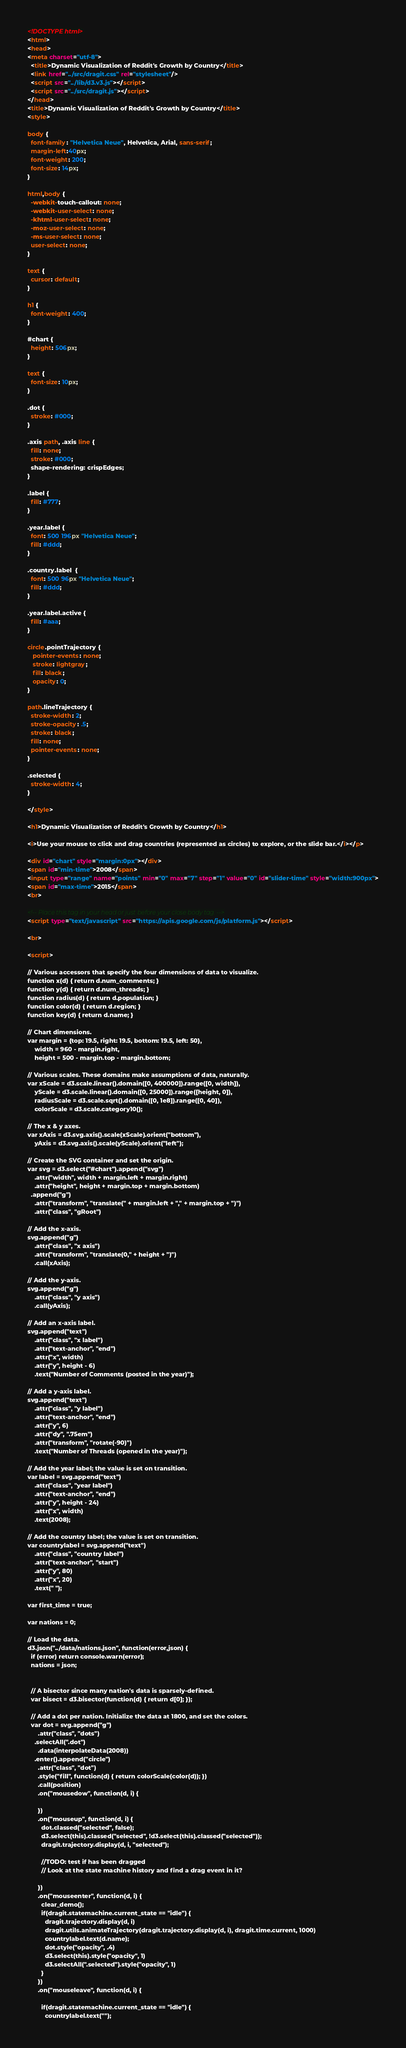Convert code to text. <code><loc_0><loc_0><loc_500><loc_500><_HTML_><!DOCTYPE html>
<html>
<head>
<meta charset="utf-8">
  <title>Dynamic Visualization of Reddit's Growth by Country</title>
  <link href="../src/dragit.css" rel="stylesheet"/>
  <script src="../lib/d3.v3.js"></script>
  <script src="../src/dragit.js"></script>
</head>
<title>Dynamic Visualization of Reddit's Growth by Country</title>
<style>

body {
  font-family: "Helvetica Neue", Helvetica, Arial, sans-serif;
  margin-left:40px;
  font-weight: 200;
  font-size: 14px;
}

html,body {
  -webkit-touch-callout: none;
  -webkit-user-select: none;
  -khtml-user-select: none;
  -moz-user-select: none;
  -ms-user-select: none;
  user-select: none;
}

text {
  cursor: default;
}

h1 {
  font-weight: 400;
}

#chart {
  height: 506px;
}

text {
  font-size: 10px;
}

.dot {
  stroke: #000;
}

.axis path, .axis line {
  fill: none;
  stroke: #000;
  shape-rendering: crispEdges;
}

.label {
  fill: #777;
}

.year.label {
  font: 500 196px "Helvetica Neue";
  fill: #ddd;
}

.country.label  {
  font: 500 96px "Helvetica Neue";
  fill: #ddd;
}

.year.label.active {
  fill: #aaa;
}

circle.pointTrajectory {
   pointer-events: none;
   stroke: lightgray;
   fill: black;
   opacity: 0;
}

path.lineTrajectory {
  stroke-width: 2;
  stroke-opacity: .5;
  stroke: black;
  fill: none;
  pointer-events: none;
}

.selected {
  stroke-width: 4;
}

</style>

<h1>Dynamic Visualization of Reddit's Growth by Country</h1>

<i>Use your mouse to click and drag countries (represented as circles) to explore, or the slide bar.</i></p>

<div id="chart" style="margin:0px"></div>
<span id="min-time">2008</span> 
<input type="range" name="points" min="0" max="7" step="1" value="0" id="slider-time" style="width:900px">
<span id="max-time">2015</span>
<br>

<!-- Place this tag in your head or just before your close body tag. -->
<script type="text/javascript" src="https://apis.google.com/js/platform.js"></script>

<br>

<script>

// Various accessors that specify the four dimensions of data to visualize.
function x(d) { return d.num_comments; }
function y(d) { return d.num_threads; }
function radius(d) { return d.population; }
function color(d) { return d.region; }
function key(d) { return d.name; }

// Chart dimensions.
var margin = {top: 19.5, right: 19.5, bottom: 19.5, left: 50},
    width = 960 - margin.right,
    height = 500 - margin.top - margin.bottom;

// Various scales. These domains make assumptions of data, naturally.
var xScale = d3.scale.linear().domain([0, 400000]).range([0, width]),
    yScale = d3.scale.linear().domain([0, 25000]).range([height, 0]),
    radiusScale = d3.scale.sqrt().domain([0, 1e8]).range([0, 40]),
    colorScale = d3.scale.category10();

// The x & y axes.
var xAxis = d3.svg.axis().scale(xScale).orient("bottom"),
    yAxis = d3.svg.axis().scale(yScale).orient("left");

// Create the SVG container and set the origin.
var svg = d3.select("#chart").append("svg")
    .attr("width", width + margin.left + margin.right)
    .attr("height", height + margin.top + margin.bottom)
  .append("g")
    .attr("transform", "translate(" + margin.left + "," + margin.top + ")")
    .attr("class", "gRoot")

// Add the x-axis.
svg.append("g")
    .attr("class", "x axis")
    .attr("transform", "translate(0," + height + ")")
    .call(xAxis);

// Add the y-axis.
svg.append("g")
    .attr("class", "y axis")
    .call(yAxis);

// Add an x-axis label.
svg.append("text")
    .attr("class", "x label")
    .attr("text-anchor", "end")
    .attr("x", width)
    .attr("y", height - 6)
    .text("Number of Comments (posted in the year)");

// Add a y-axis label.
svg.append("text")
    .attr("class", "y label")
    .attr("text-anchor", "end")
    .attr("y", 6)
    .attr("dy", ".75em")
    .attr("transform", "rotate(-90)")
    .text("Number of Threads (opened in the year)");

// Add the year label; the value is set on transition.
var label = svg.append("text")
    .attr("class", "year label")
    .attr("text-anchor", "end")
    .attr("y", height - 24)
    .attr("x", width)
    .text(2008);

// Add the country label; the value is set on transition.
var countrylabel = svg.append("text")
    .attr("class", "country label")
    .attr("text-anchor", "start")
    .attr("y", 80)
    .attr("x", 20)
    .text(" ");

var first_time = true;

var nations = 0;

// Load the data.
d3.json("../data/nations.json", function(error,json) {
  if (error) return console.warn(error);
  nations = json;


  // A bisector since many nation's data is sparsely-defined.
  var bisect = d3.bisector(function(d) { return d[0]; });

  // Add a dot per nation. Initialize the data at 1800, and set the colors.
  var dot = svg.append("g")
      .attr("class", "dots")
    .selectAll(".dot")
      .data(interpolateData(2008))
    .enter().append("circle")
      .attr("class", "dot")
      .style("fill", function(d) { return colorScale(color(d)); })
      .call(position)
      .on("mousedow", function(d, i) {

      })
      .on("mouseup", function(d, i) {
        dot.classed("selected", false);
        d3.select(this).classed("selected", !d3.select(this).classed("selected"));
        dragit.trajectory.display(d, i, "selected");

        //TODO: test if has been dragged
        // Look at the state machine history and find a drag event in it?

      })
      .on("mouseenter", function(d, i) {
        clear_demo();
        if(dragit.statemachine.current_state == "idle") {
          dragit.trajectory.display(d, i)
          dragit.utils.animateTrajectory(dragit.trajectory.display(d, i), dragit.time.current, 1000)
          countrylabel.text(d.name);
          dot.style("opacity", .4)
          d3.select(this).style("opacity", 1)
          d3.selectAll(".selected").style("opacity", 1)
        }
      })
      .on("mouseleave", function(d, i) {

        if(dragit.statemachine.current_state == "idle") {
          countrylabel.text("");</code> 